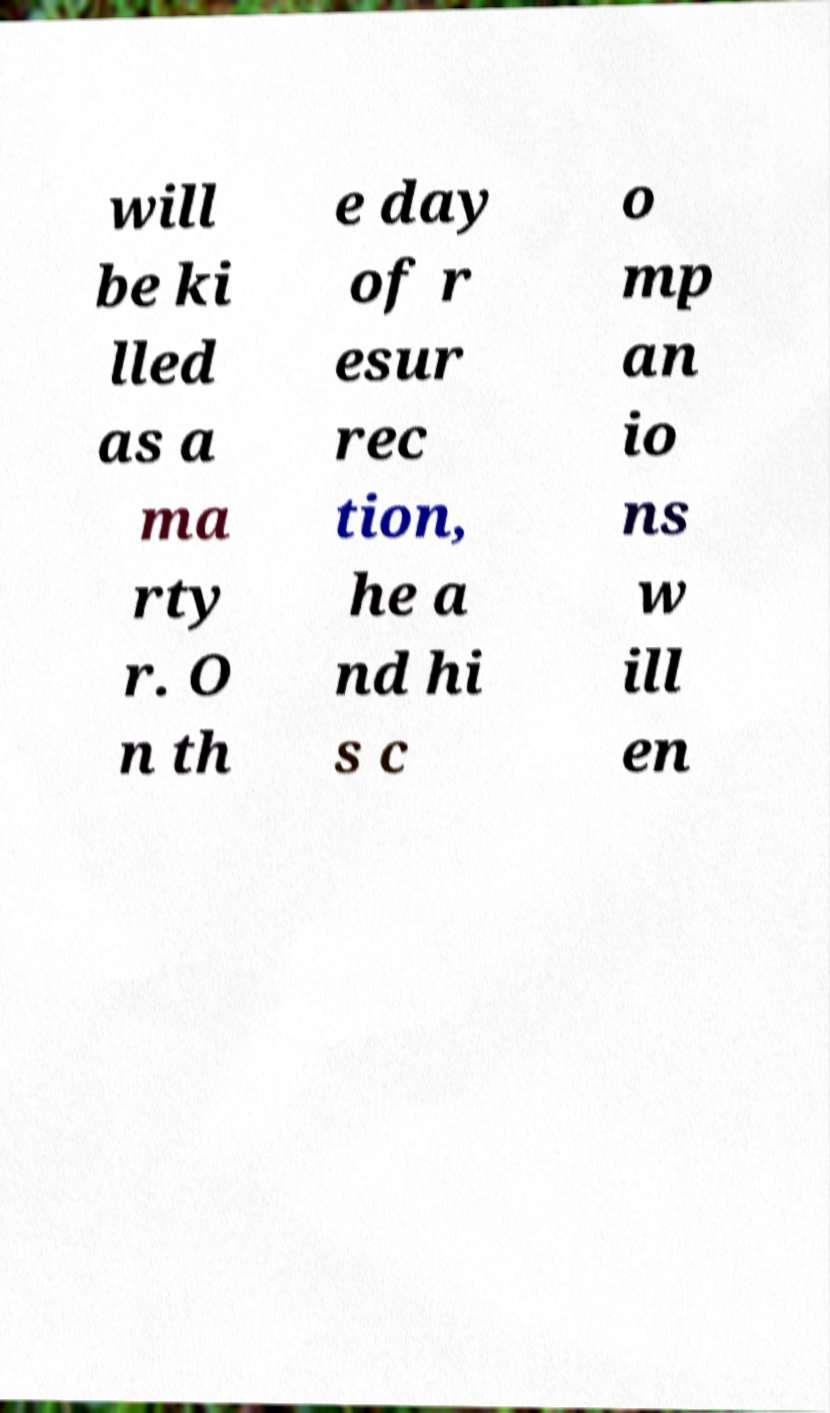Can you accurately transcribe the text from the provided image for me? will be ki lled as a ma rty r. O n th e day of r esur rec tion, he a nd hi s c o mp an io ns w ill en 